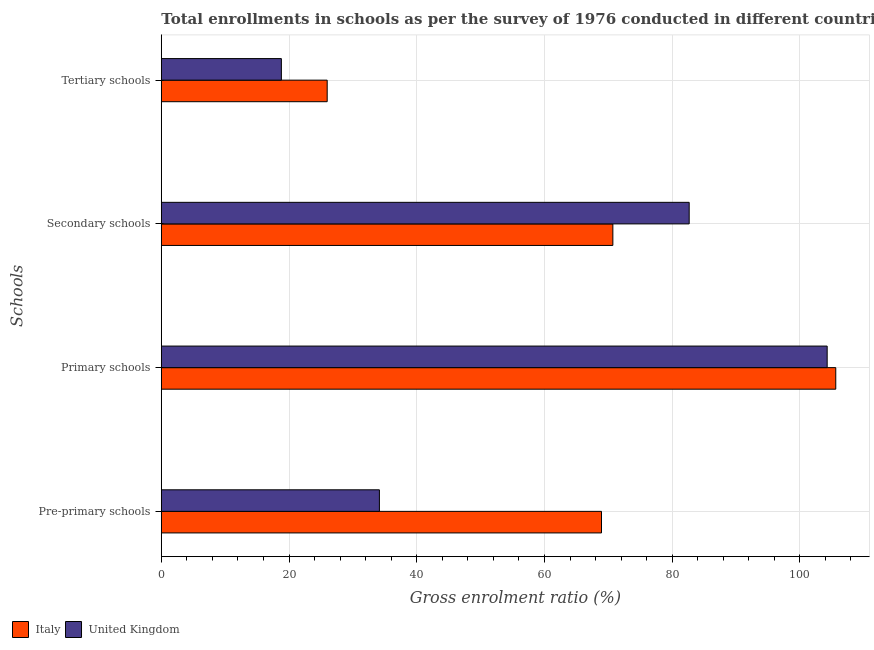How many different coloured bars are there?
Give a very brief answer. 2. Are the number of bars on each tick of the Y-axis equal?
Make the answer very short. Yes. How many bars are there on the 3rd tick from the bottom?
Make the answer very short. 2. What is the label of the 1st group of bars from the top?
Provide a succinct answer. Tertiary schools. What is the gross enrolment ratio in tertiary schools in United Kingdom?
Make the answer very short. 18.8. Across all countries, what is the maximum gross enrolment ratio in secondary schools?
Provide a succinct answer. 82.66. Across all countries, what is the minimum gross enrolment ratio in primary schools?
Provide a succinct answer. 104.27. What is the total gross enrolment ratio in tertiary schools in the graph?
Your response must be concise. 44.78. What is the difference between the gross enrolment ratio in primary schools in United Kingdom and that in Italy?
Provide a short and direct response. -1.35. What is the difference between the gross enrolment ratio in secondary schools in United Kingdom and the gross enrolment ratio in tertiary schools in Italy?
Offer a terse response. 56.69. What is the average gross enrolment ratio in secondary schools per country?
Keep it short and to the point. 76.69. What is the difference between the gross enrolment ratio in primary schools and gross enrolment ratio in tertiary schools in United Kingdom?
Provide a short and direct response. 85.47. What is the ratio of the gross enrolment ratio in primary schools in Italy to that in United Kingdom?
Provide a succinct answer. 1.01. Is the difference between the gross enrolment ratio in primary schools in Italy and United Kingdom greater than the difference between the gross enrolment ratio in secondary schools in Italy and United Kingdom?
Offer a very short reply. Yes. What is the difference between the highest and the second highest gross enrolment ratio in pre-primary schools?
Keep it short and to the point. 34.78. What is the difference between the highest and the lowest gross enrolment ratio in pre-primary schools?
Offer a very short reply. 34.78. Is the sum of the gross enrolment ratio in pre-primary schools in Italy and United Kingdom greater than the maximum gross enrolment ratio in secondary schools across all countries?
Your answer should be compact. Yes. Is it the case that in every country, the sum of the gross enrolment ratio in pre-primary schools and gross enrolment ratio in tertiary schools is greater than the sum of gross enrolment ratio in primary schools and gross enrolment ratio in secondary schools?
Your answer should be very brief. No. What does the 2nd bar from the top in Pre-primary schools represents?
Your response must be concise. Italy. What does the 2nd bar from the bottom in Pre-primary schools represents?
Ensure brevity in your answer.  United Kingdom. Are all the bars in the graph horizontal?
Offer a terse response. Yes. How many countries are there in the graph?
Your response must be concise. 2. What is the difference between two consecutive major ticks on the X-axis?
Make the answer very short. 20. Does the graph contain any zero values?
Ensure brevity in your answer.  No. Does the graph contain grids?
Ensure brevity in your answer.  Yes. What is the title of the graph?
Ensure brevity in your answer.  Total enrollments in schools as per the survey of 1976 conducted in different countries. Does "Cote d'Ivoire" appear as one of the legend labels in the graph?
Offer a very short reply. No. What is the label or title of the Y-axis?
Make the answer very short. Schools. What is the Gross enrolment ratio (%) in Italy in Pre-primary schools?
Offer a very short reply. 68.93. What is the Gross enrolment ratio (%) in United Kingdom in Pre-primary schools?
Your response must be concise. 34.15. What is the Gross enrolment ratio (%) of Italy in Primary schools?
Ensure brevity in your answer.  105.62. What is the Gross enrolment ratio (%) of United Kingdom in Primary schools?
Keep it short and to the point. 104.27. What is the Gross enrolment ratio (%) in Italy in Secondary schools?
Give a very brief answer. 70.71. What is the Gross enrolment ratio (%) in United Kingdom in Secondary schools?
Your answer should be very brief. 82.66. What is the Gross enrolment ratio (%) of Italy in Tertiary schools?
Offer a terse response. 25.97. What is the Gross enrolment ratio (%) of United Kingdom in Tertiary schools?
Make the answer very short. 18.8. Across all Schools, what is the maximum Gross enrolment ratio (%) of Italy?
Your response must be concise. 105.62. Across all Schools, what is the maximum Gross enrolment ratio (%) of United Kingdom?
Offer a terse response. 104.27. Across all Schools, what is the minimum Gross enrolment ratio (%) of Italy?
Keep it short and to the point. 25.97. Across all Schools, what is the minimum Gross enrolment ratio (%) in United Kingdom?
Your answer should be very brief. 18.8. What is the total Gross enrolment ratio (%) of Italy in the graph?
Your response must be concise. 271.24. What is the total Gross enrolment ratio (%) in United Kingdom in the graph?
Make the answer very short. 239.89. What is the difference between the Gross enrolment ratio (%) of Italy in Pre-primary schools and that in Primary schools?
Provide a succinct answer. -36.69. What is the difference between the Gross enrolment ratio (%) in United Kingdom in Pre-primary schools and that in Primary schools?
Offer a terse response. -70.12. What is the difference between the Gross enrolment ratio (%) in Italy in Pre-primary schools and that in Secondary schools?
Give a very brief answer. -1.78. What is the difference between the Gross enrolment ratio (%) of United Kingdom in Pre-primary schools and that in Secondary schools?
Ensure brevity in your answer.  -48.51. What is the difference between the Gross enrolment ratio (%) in Italy in Pre-primary schools and that in Tertiary schools?
Offer a terse response. 42.96. What is the difference between the Gross enrolment ratio (%) in United Kingdom in Pre-primary schools and that in Tertiary schools?
Ensure brevity in your answer.  15.35. What is the difference between the Gross enrolment ratio (%) in Italy in Primary schools and that in Secondary schools?
Give a very brief answer. 34.91. What is the difference between the Gross enrolment ratio (%) of United Kingdom in Primary schools and that in Secondary schools?
Provide a succinct answer. 21.61. What is the difference between the Gross enrolment ratio (%) in Italy in Primary schools and that in Tertiary schools?
Make the answer very short. 79.64. What is the difference between the Gross enrolment ratio (%) of United Kingdom in Primary schools and that in Tertiary schools?
Give a very brief answer. 85.47. What is the difference between the Gross enrolment ratio (%) of Italy in Secondary schools and that in Tertiary schools?
Offer a very short reply. 44.74. What is the difference between the Gross enrolment ratio (%) of United Kingdom in Secondary schools and that in Tertiary schools?
Your answer should be compact. 63.86. What is the difference between the Gross enrolment ratio (%) in Italy in Pre-primary schools and the Gross enrolment ratio (%) in United Kingdom in Primary schools?
Your answer should be very brief. -35.34. What is the difference between the Gross enrolment ratio (%) in Italy in Pre-primary schools and the Gross enrolment ratio (%) in United Kingdom in Secondary schools?
Your response must be concise. -13.73. What is the difference between the Gross enrolment ratio (%) in Italy in Pre-primary schools and the Gross enrolment ratio (%) in United Kingdom in Tertiary schools?
Ensure brevity in your answer.  50.13. What is the difference between the Gross enrolment ratio (%) in Italy in Primary schools and the Gross enrolment ratio (%) in United Kingdom in Secondary schools?
Your answer should be very brief. 22.95. What is the difference between the Gross enrolment ratio (%) in Italy in Primary schools and the Gross enrolment ratio (%) in United Kingdom in Tertiary schools?
Your answer should be very brief. 86.82. What is the difference between the Gross enrolment ratio (%) in Italy in Secondary schools and the Gross enrolment ratio (%) in United Kingdom in Tertiary schools?
Offer a very short reply. 51.91. What is the average Gross enrolment ratio (%) in Italy per Schools?
Offer a very short reply. 67.81. What is the average Gross enrolment ratio (%) in United Kingdom per Schools?
Keep it short and to the point. 59.97. What is the difference between the Gross enrolment ratio (%) in Italy and Gross enrolment ratio (%) in United Kingdom in Pre-primary schools?
Keep it short and to the point. 34.78. What is the difference between the Gross enrolment ratio (%) in Italy and Gross enrolment ratio (%) in United Kingdom in Primary schools?
Offer a very short reply. 1.35. What is the difference between the Gross enrolment ratio (%) in Italy and Gross enrolment ratio (%) in United Kingdom in Secondary schools?
Offer a very short reply. -11.95. What is the difference between the Gross enrolment ratio (%) of Italy and Gross enrolment ratio (%) of United Kingdom in Tertiary schools?
Ensure brevity in your answer.  7.17. What is the ratio of the Gross enrolment ratio (%) in Italy in Pre-primary schools to that in Primary schools?
Keep it short and to the point. 0.65. What is the ratio of the Gross enrolment ratio (%) in United Kingdom in Pre-primary schools to that in Primary schools?
Make the answer very short. 0.33. What is the ratio of the Gross enrolment ratio (%) of Italy in Pre-primary schools to that in Secondary schools?
Give a very brief answer. 0.97. What is the ratio of the Gross enrolment ratio (%) of United Kingdom in Pre-primary schools to that in Secondary schools?
Make the answer very short. 0.41. What is the ratio of the Gross enrolment ratio (%) in Italy in Pre-primary schools to that in Tertiary schools?
Your answer should be very brief. 2.65. What is the ratio of the Gross enrolment ratio (%) in United Kingdom in Pre-primary schools to that in Tertiary schools?
Your response must be concise. 1.82. What is the ratio of the Gross enrolment ratio (%) of Italy in Primary schools to that in Secondary schools?
Ensure brevity in your answer.  1.49. What is the ratio of the Gross enrolment ratio (%) of United Kingdom in Primary schools to that in Secondary schools?
Your response must be concise. 1.26. What is the ratio of the Gross enrolment ratio (%) of Italy in Primary schools to that in Tertiary schools?
Keep it short and to the point. 4.07. What is the ratio of the Gross enrolment ratio (%) in United Kingdom in Primary schools to that in Tertiary schools?
Your answer should be compact. 5.55. What is the ratio of the Gross enrolment ratio (%) of Italy in Secondary schools to that in Tertiary schools?
Your response must be concise. 2.72. What is the ratio of the Gross enrolment ratio (%) of United Kingdom in Secondary schools to that in Tertiary schools?
Make the answer very short. 4.4. What is the difference between the highest and the second highest Gross enrolment ratio (%) in Italy?
Ensure brevity in your answer.  34.91. What is the difference between the highest and the second highest Gross enrolment ratio (%) of United Kingdom?
Give a very brief answer. 21.61. What is the difference between the highest and the lowest Gross enrolment ratio (%) in Italy?
Offer a terse response. 79.64. What is the difference between the highest and the lowest Gross enrolment ratio (%) in United Kingdom?
Offer a terse response. 85.47. 